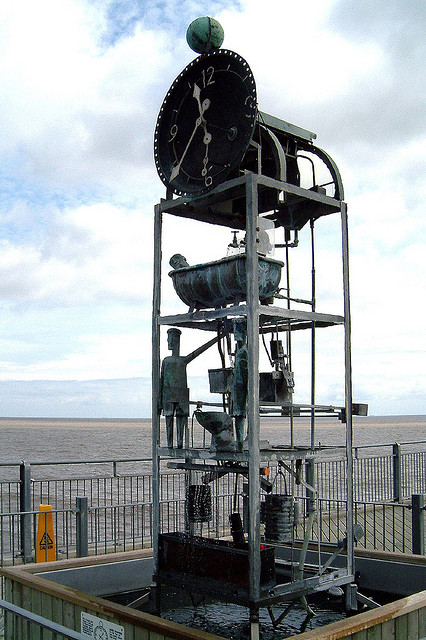Identify the text displayed in this image. 9 12 3 6 